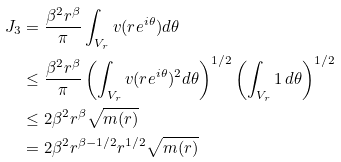Convert formula to latex. <formula><loc_0><loc_0><loc_500><loc_500>J _ { 3 } & = \frac { \beta ^ { 2 } r ^ { \beta } } { \pi } \int _ { V _ { r } } v ( r e ^ { i \theta } ) d \theta \\ & \leq \frac { \beta ^ { 2 } r ^ { \beta } } { \pi } \left ( \int _ { V _ { r } } v ( r e ^ { i \theta } ) ^ { 2 } d \theta \right ) ^ { 1 / 2 } \left ( \int _ { V _ { r } } 1 \, d \theta \right ) ^ { 1 / 2 } \\ & \leq 2 \beta ^ { 2 } r ^ { \beta } \sqrt { m ( r ) } \\ & = 2 \beta ^ { 2 } r ^ { \beta - 1 / 2 } r ^ { 1 / 2 } \sqrt { m ( r ) }</formula> 